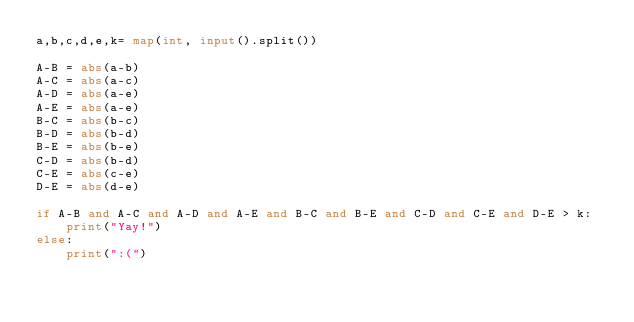<code> <loc_0><loc_0><loc_500><loc_500><_Python_>a,b,c,d,e,k= map(int, input().split())

A-B = abs(a-b)
A-C = abs(a-c)
A-D = abs(a-e)
A-E = abs(a-e)
B-C = abs(b-c)
B-D = abs(b-d)
B-E = abs(b-e)
C-D = abs(b-d)
C-E = abs(c-e)
D-E = abs(d-e)

if A-B and A-C and A-D and A-E and B-C and B-E and C-D and C-E and D-E > k:
    print("Yay!")
else:
    print(":(")</code> 